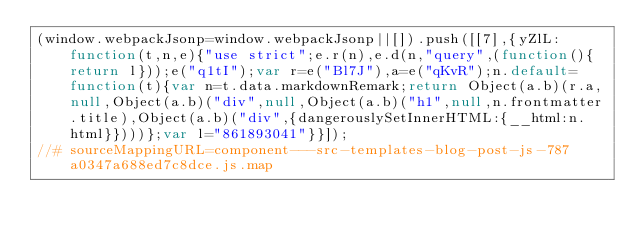<code> <loc_0><loc_0><loc_500><loc_500><_JavaScript_>(window.webpackJsonp=window.webpackJsonp||[]).push([[7],{yZlL:function(t,n,e){"use strict";e.r(n),e.d(n,"query",(function(){return l}));e("q1tI");var r=e("Bl7J"),a=e("qKvR");n.default=function(t){var n=t.data.markdownRemark;return Object(a.b)(r.a,null,Object(a.b)("div",null,Object(a.b)("h1",null,n.frontmatter.title),Object(a.b)("div",{dangerouslySetInnerHTML:{__html:n.html}})))};var l="861893041"}}]);
//# sourceMappingURL=component---src-templates-blog-post-js-787a0347a688ed7c8dce.js.map</code> 